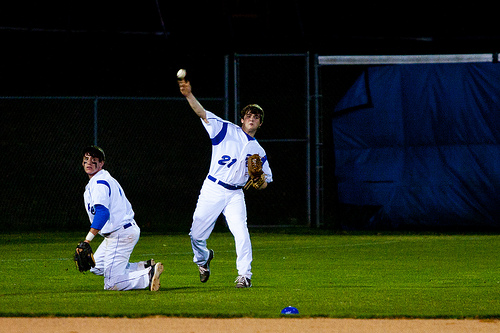How many players are in the picture? There are exactly 2 players visible in the picture, engaged in a nighttime baseball game. One player is crouched down, likely playing as a catcher, while the other is standing and appears to be in the motion of pitching the ball. 